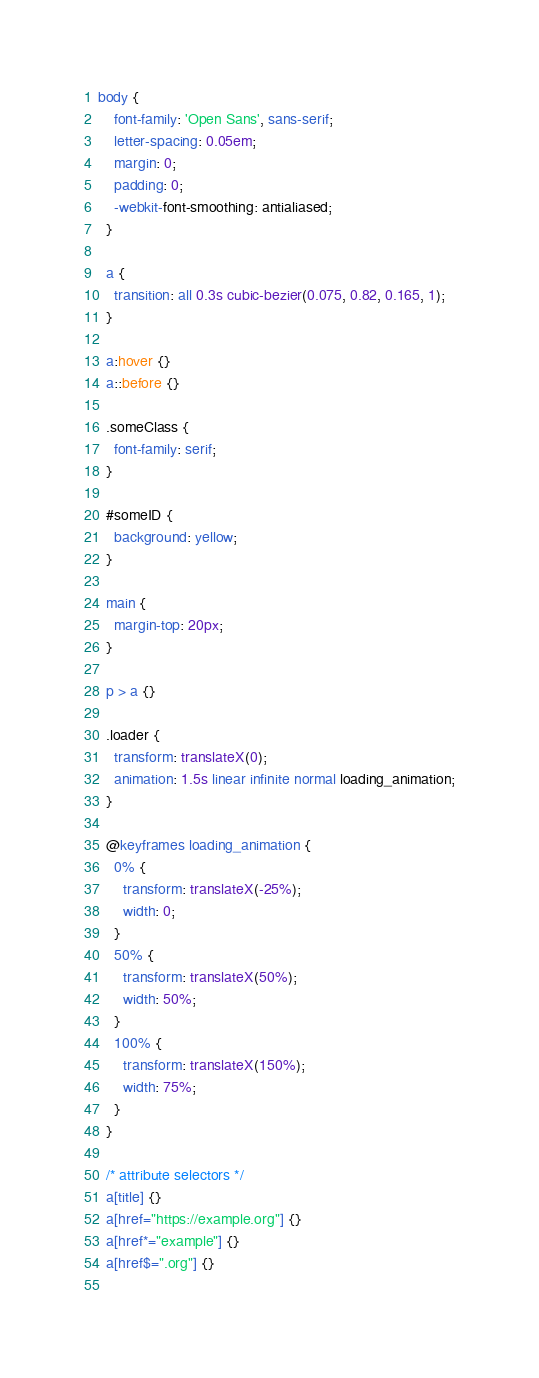Convert code to text. <code><loc_0><loc_0><loc_500><loc_500><_CSS_>body {
    font-family: 'Open Sans', sans-serif;
    letter-spacing: 0.05em;
    margin: 0;
    padding: 0;
    -webkit-font-smoothing: antialiased;
  }
  
  a {
    transition: all 0.3s cubic-bezier(0.075, 0.82, 0.165, 1);
  }
  
  a:hover {}
  a::before {}
  
  .someClass {
    font-family: serif;
  }
  
  #someID {
    background: yellow;
  }
  
  main {
    margin-top: 20px;
  }
  
  p > a {}
  
  .loader {
    transform: translateX(0);
    animation: 1.5s linear infinite normal loading_animation;
  }
  
  @keyframes loading_animation {
    0% {
      transform: translateX(-25%);
      width: 0;
    }
    50% {
      transform: translateX(50%);
      width: 50%;
    }
    100% {
      transform: translateX(150%);
      width: 75%;
    }
  }
  
  /* attribute selectors */
  a[title] {}
  a[href="https://example.org"] {}
  a[href*="example"] {}
  a[href$=".org"] {}
  </code> 